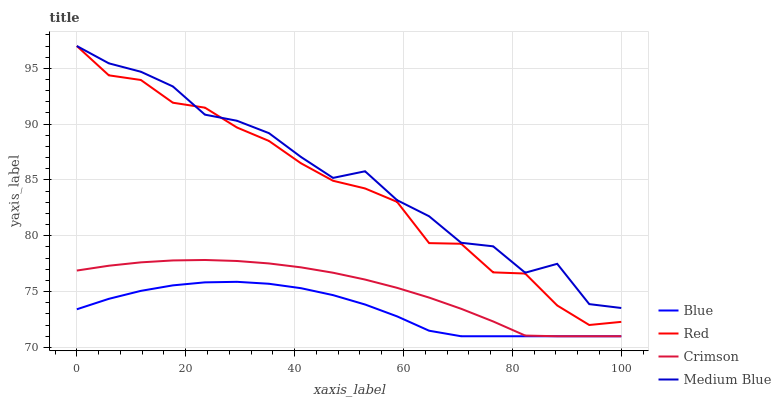Does Blue have the minimum area under the curve?
Answer yes or no. Yes. Does Medium Blue have the maximum area under the curve?
Answer yes or no. Yes. Does Crimson have the minimum area under the curve?
Answer yes or no. No. Does Crimson have the maximum area under the curve?
Answer yes or no. No. Is Crimson the smoothest?
Answer yes or no. Yes. Is Medium Blue the roughest?
Answer yes or no. Yes. Is Medium Blue the smoothest?
Answer yes or no. No. Is Crimson the roughest?
Answer yes or no. No. Does Blue have the lowest value?
Answer yes or no. Yes. Does Medium Blue have the lowest value?
Answer yes or no. No. Does Red have the highest value?
Answer yes or no. Yes. Does Crimson have the highest value?
Answer yes or no. No. Is Blue less than Medium Blue?
Answer yes or no. Yes. Is Medium Blue greater than Crimson?
Answer yes or no. Yes. Does Crimson intersect Blue?
Answer yes or no. Yes. Is Crimson less than Blue?
Answer yes or no. No. Is Crimson greater than Blue?
Answer yes or no. No. Does Blue intersect Medium Blue?
Answer yes or no. No. 